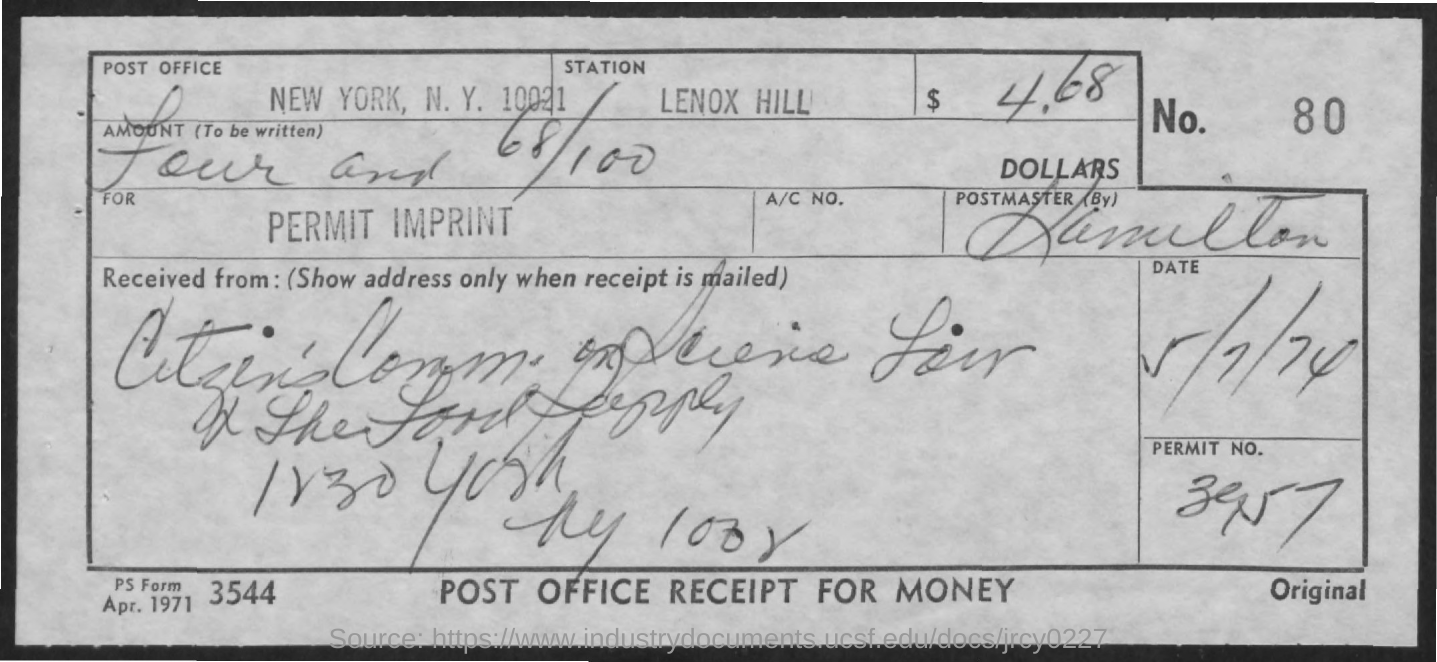What is the name of the Station?
Provide a succinct answer. Lenox Hill. What is the Permit number?
Your answer should be compact. 3957. What is the Form Number?
Make the answer very short. 3544. What is the name of the Post Office?
Give a very brief answer. New York, N.Y. 10021. What is the date mentioned in the document?
Ensure brevity in your answer.  5/7/74. 